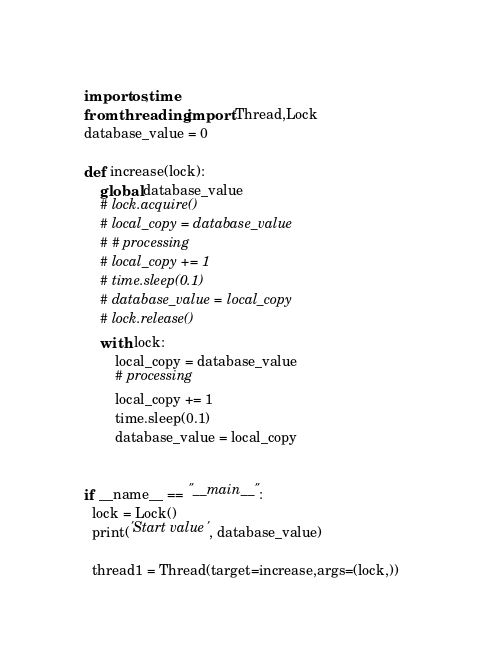Convert code to text. <code><loc_0><loc_0><loc_500><loc_500><_Python_>import os,time
from threading import Thread,Lock
database_value = 0

def increase(lock):
    global database_value
    # lock.acquire()
    # local_copy = database_value
    # # processing
    # local_copy += 1
    # time.sleep(0.1)
    # database_value = local_copy
    # lock.release()
    with lock:
        local_copy = database_value
        # processing
        local_copy += 1
        time.sleep(0.1)
        database_value = local_copy
    

if __name__ == "__main__":
  lock = Lock()
  print('Start value', database_value)

  thread1 = Thread(target=increase,args=(lock,))</code> 